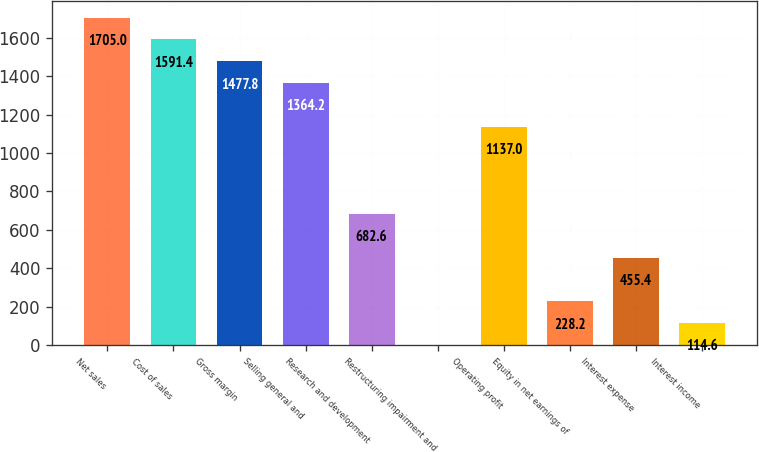Convert chart. <chart><loc_0><loc_0><loc_500><loc_500><bar_chart><fcel>Net sales<fcel>Cost of sales<fcel>Gross margin<fcel>Selling general and<fcel>Research and development<fcel>Restructuring impairment and<fcel>Operating profit<fcel>Equity in net earnings of<fcel>Interest expense<fcel>Interest income<nl><fcel>1705<fcel>1591.4<fcel>1477.8<fcel>1364.2<fcel>682.6<fcel>1<fcel>1137<fcel>228.2<fcel>455.4<fcel>114.6<nl></chart> 